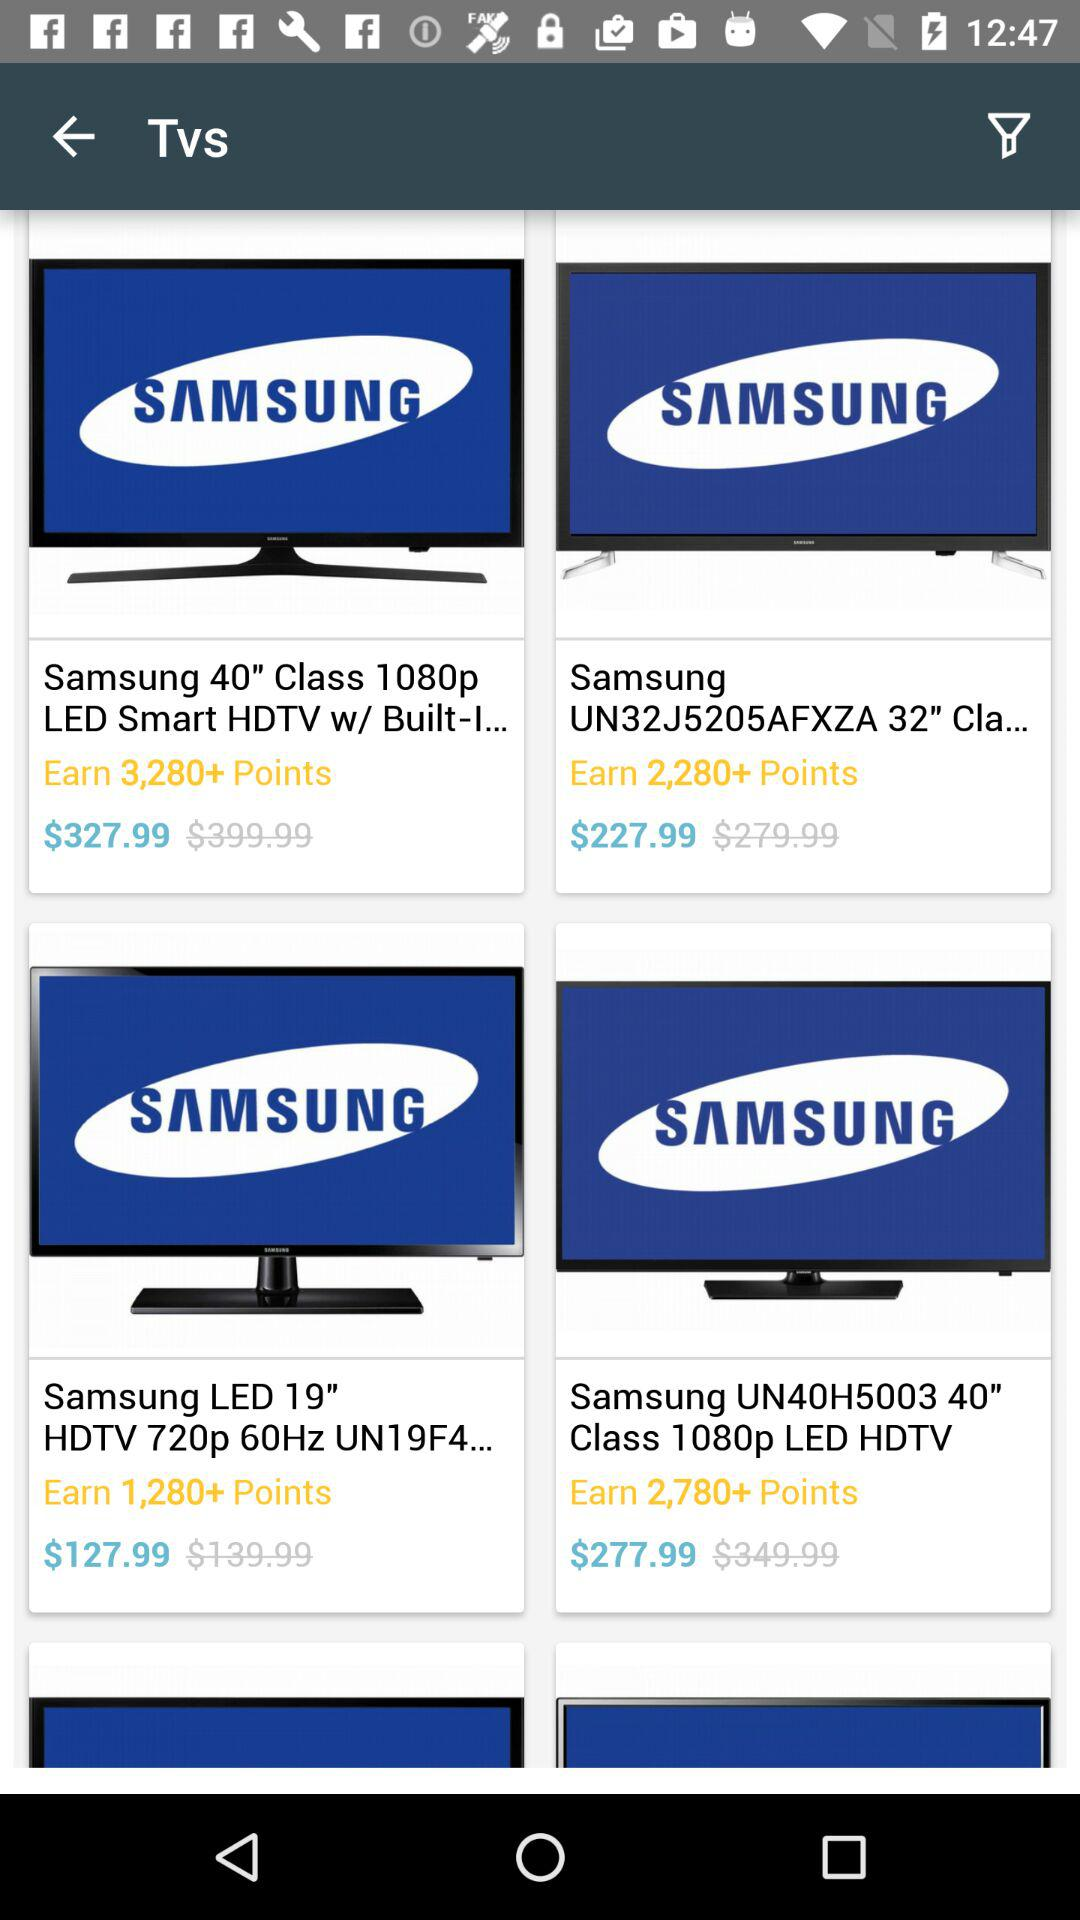How many points can we earn with the "Samsung 40" Class 1080p LED Smart HDTV"? You can earn 3,280+ points. 